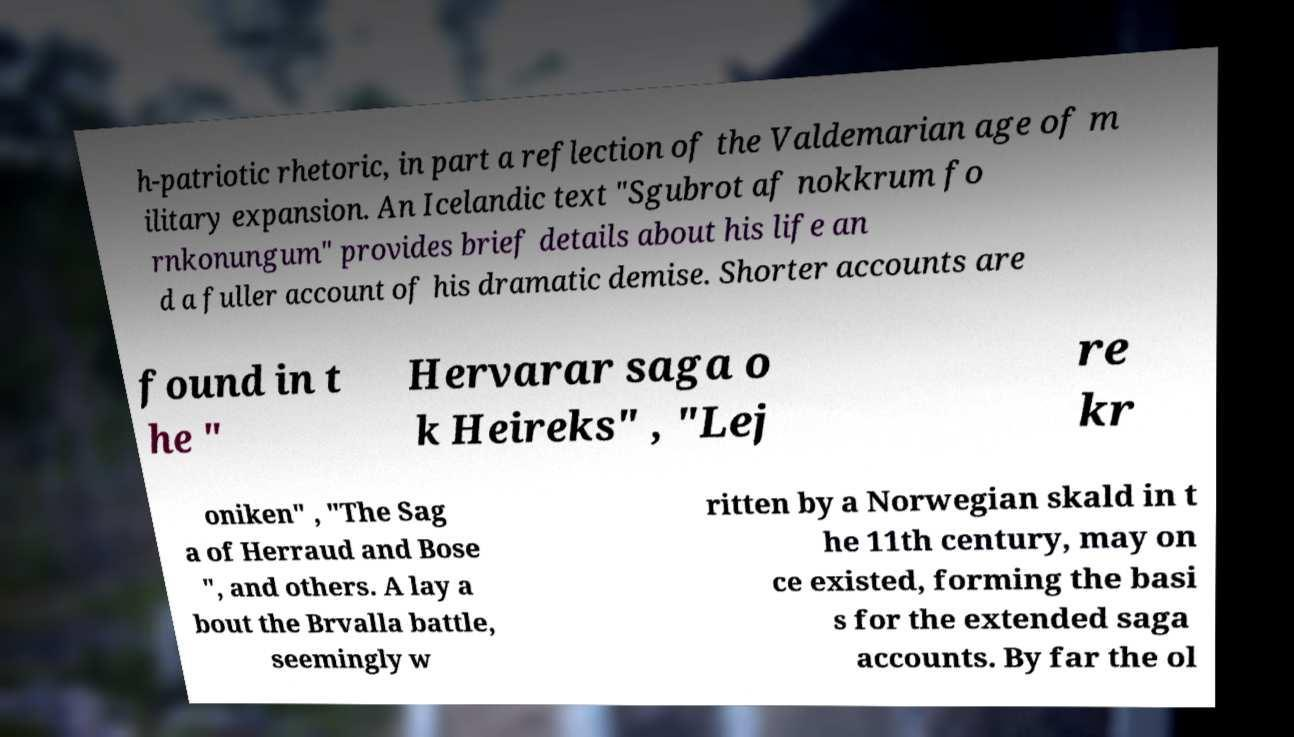I need the written content from this picture converted into text. Can you do that? h-patriotic rhetoric, in part a reflection of the Valdemarian age of m ilitary expansion. An Icelandic text "Sgubrot af nokkrum fo rnkonungum" provides brief details about his life an d a fuller account of his dramatic demise. Shorter accounts are found in t he " Hervarar saga o k Heireks" , "Lej re kr oniken" , "The Sag a of Herraud and Bose ", and others. A lay a bout the Brvalla battle, seemingly w ritten by a Norwegian skald in t he 11th century, may on ce existed, forming the basi s for the extended saga accounts. By far the ol 